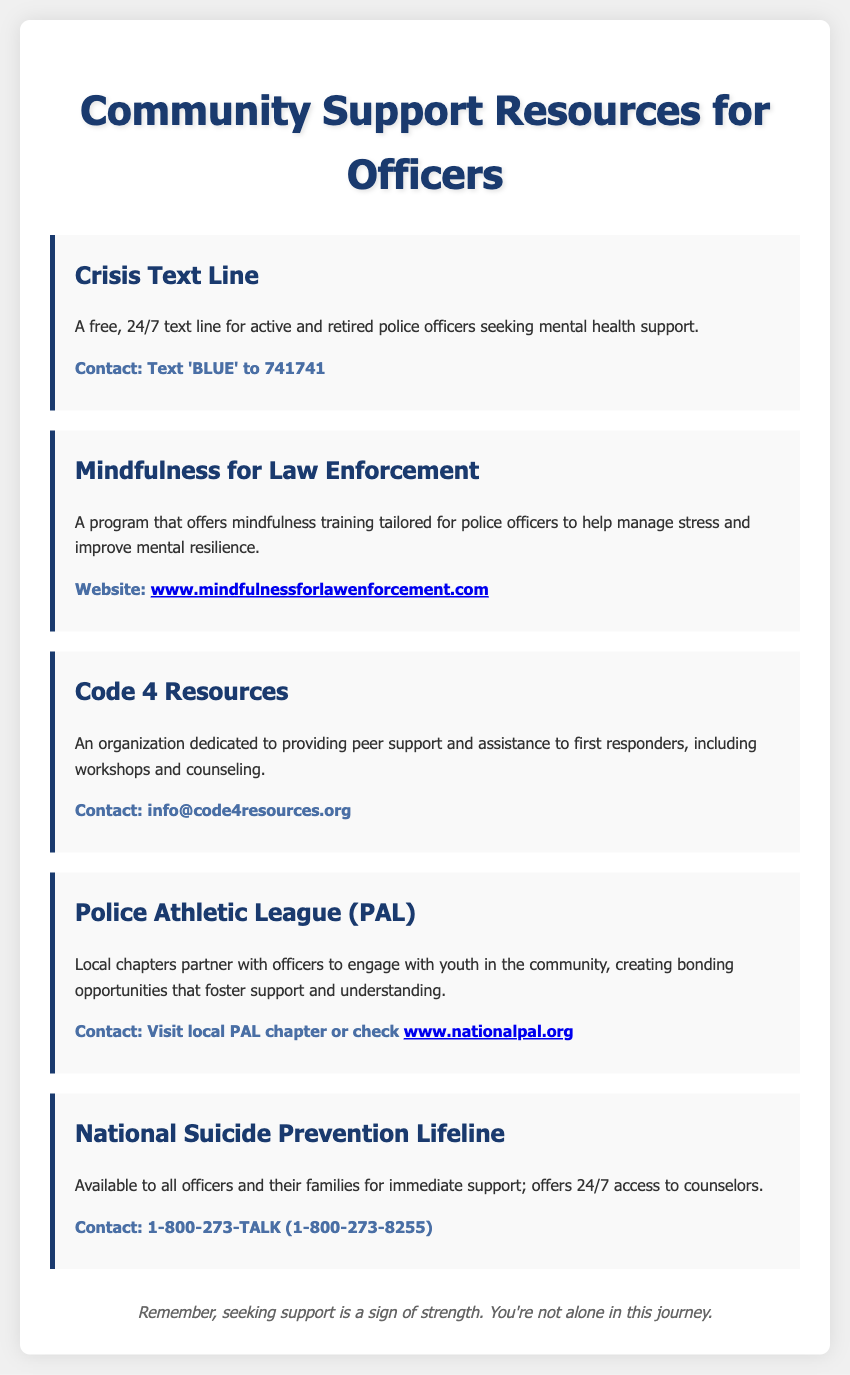what is the contact method for the Crisis Text Line? The document states that the Crisis Text Line can be contacted by texting 'BLUE' to 741741.
Answer: Text 'BLUE' to 741741 what organization provides peer support and counseling? The document mentions Code 4 Resources as an organization dedicated to providing peer support and assistance to first responders.
Answer: Code 4 Resources what is the website for Mindfulness for Law Enforcement? The document provides a link to the website for mindfulness training tailored for police officers.
Answer: www.mindfulnessforlawenforcement.com what is the contact number for the National Suicide Prevention Lifeline? The document lists the contact number for the National Suicide Prevention Lifeline as 1-800-273-TALK.
Answer: 1-800-273-TALK how does the Police Athletic League engage with the community? The document explains that local chapters partner with officers to engage with youth in the community.
Answer: Engage with youth what does the footer message convey? The footer message emphasizes the importance of seeking support as a sign of strength and reassures officers they are not alone.
Answer: Seeking support is a sign of strength what type of training does the Mindfulness for Law Enforcement program offer? The document specifies that the program offers mindfulness training tailored for police officers.
Answer: Mindfulness training what is the primary purpose of the resources listed in the document? The document outlines various resources aimed at supporting police officers through mental health services and stress management programs.
Answer: Support police officers 